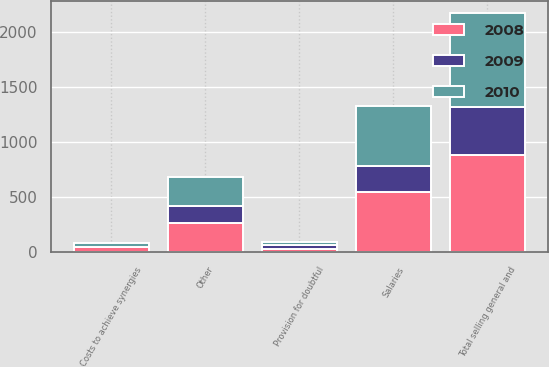<chart> <loc_0><loc_0><loc_500><loc_500><stacked_bar_chart><ecel><fcel>Salaries<fcel>Provision for doubtful<fcel>Costs to achieve synergies<fcel>Other<fcel>Total selling general and<nl><fcel>2010<fcel>538.6<fcel>23.6<fcel>33.3<fcel>262.5<fcel>858<nl><fcel>2008<fcel>548.1<fcel>27.3<fcel>41.6<fcel>263.4<fcel>880.4<nl><fcel>2009<fcel>237.6<fcel>36.5<fcel>2.9<fcel>157.7<fcel>434.7<nl></chart> 